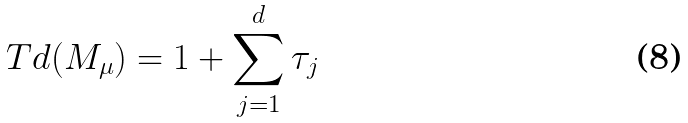<formula> <loc_0><loc_0><loc_500><loc_500>T d ( M _ { \mu } ) = 1 + \sum _ { j = 1 } ^ { d } \tau _ { j }</formula> 